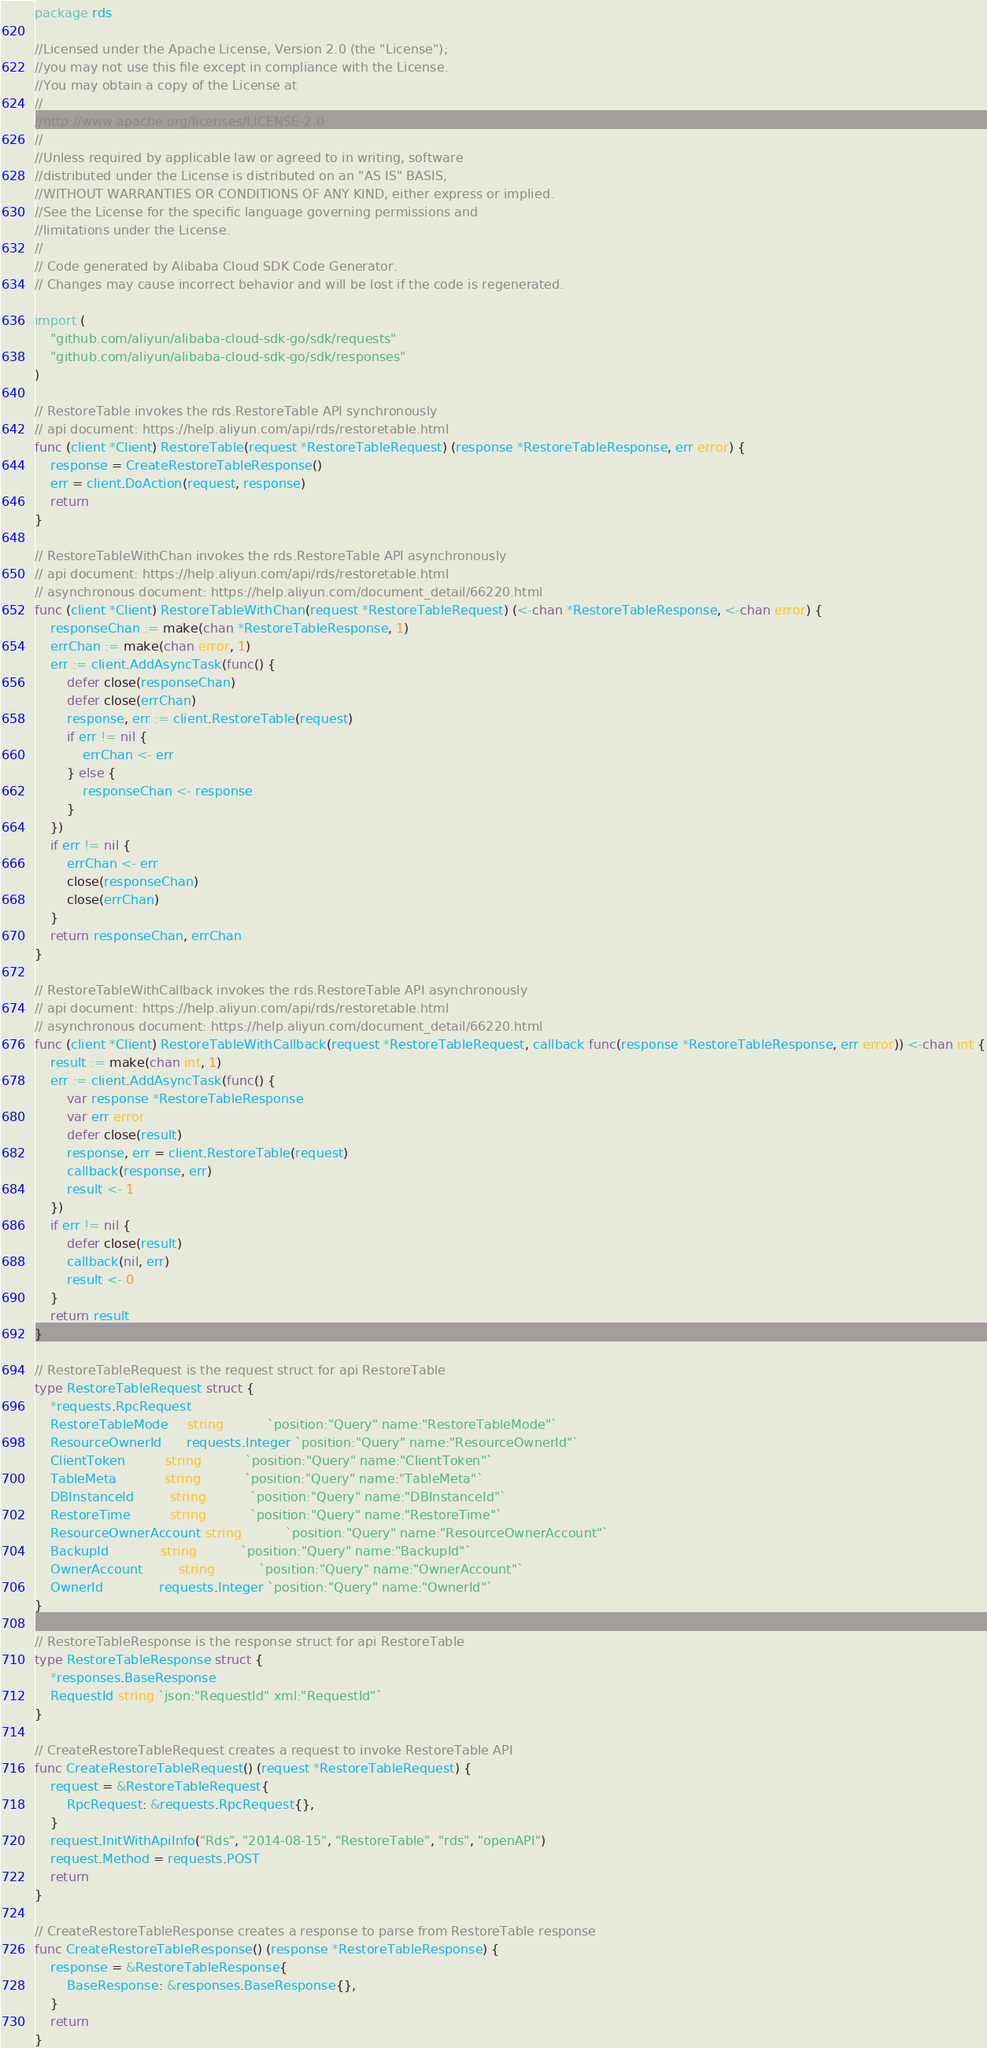Convert code to text. <code><loc_0><loc_0><loc_500><loc_500><_Go_>package rds

//Licensed under the Apache License, Version 2.0 (the "License");
//you may not use this file except in compliance with the License.
//You may obtain a copy of the License at
//
//http://www.apache.org/licenses/LICENSE-2.0
//
//Unless required by applicable law or agreed to in writing, software
//distributed under the License is distributed on an "AS IS" BASIS,
//WITHOUT WARRANTIES OR CONDITIONS OF ANY KIND, either express or implied.
//See the License for the specific language governing permissions and
//limitations under the License.
//
// Code generated by Alibaba Cloud SDK Code Generator.
// Changes may cause incorrect behavior and will be lost if the code is regenerated.

import (
	"github.com/aliyun/alibaba-cloud-sdk-go/sdk/requests"
	"github.com/aliyun/alibaba-cloud-sdk-go/sdk/responses"
)

// RestoreTable invokes the rds.RestoreTable API synchronously
// api document: https://help.aliyun.com/api/rds/restoretable.html
func (client *Client) RestoreTable(request *RestoreTableRequest) (response *RestoreTableResponse, err error) {
	response = CreateRestoreTableResponse()
	err = client.DoAction(request, response)
	return
}

// RestoreTableWithChan invokes the rds.RestoreTable API asynchronously
// api document: https://help.aliyun.com/api/rds/restoretable.html
// asynchronous document: https://help.aliyun.com/document_detail/66220.html
func (client *Client) RestoreTableWithChan(request *RestoreTableRequest) (<-chan *RestoreTableResponse, <-chan error) {
	responseChan := make(chan *RestoreTableResponse, 1)
	errChan := make(chan error, 1)
	err := client.AddAsyncTask(func() {
		defer close(responseChan)
		defer close(errChan)
		response, err := client.RestoreTable(request)
		if err != nil {
			errChan <- err
		} else {
			responseChan <- response
		}
	})
	if err != nil {
		errChan <- err
		close(responseChan)
		close(errChan)
	}
	return responseChan, errChan
}

// RestoreTableWithCallback invokes the rds.RestoreTable API asynchronously
// api document: https://help.aliyun.com/api/rds/restoretable.html
// asynchronous document: https://help.aliyun.com/document_detail/66220.html
func (client *Client) RestoreTableWithCallback(request *RestoreTableRequest, callback func(response *RestoreTableResponse, err error)) <-chan int {
	result := make(chan int, 1)
	err := client.AddAsyncTask(func() {
		var response *RestoreTableResponse
		var err error
		defer close(result)
		response, err = client.RestoreTable(request)
		callback(response, err)
		result <- 1
	})
	if err != nil {
		defer close(result)
		callback(nil, err)
		result <- 0
	}
	return result
}

// RestoreTableRequest is the request struct for api RestoreTable
type RestoreTableRequest struct {
	*requests.RpcRequest
	RestoreTableMode     string           `position:"Query" name:"RestoreTableMode"`
	ResourceOwnerId      requests.Integer `position:"Query" name:"ResourceOwnerId"`
	ClientToken          string           `position:"Query" name:"ClientToken"`
	TableMeta            string           `position:"Query" name:"TableMeta"`
	DBInstanceId         string           `position:"Query" name:"DBInstanceId"`
	RestoreTime          string           `position:"Query" name:"RestoreTime"`
	ResourceOwnerAccount string           `position:"Query" name:"ResourceOwnerAccount"`
	BackupId             string           `position:"Query" name:"BackupId"`
	OwnerAccount         string           `position:"Query" name:"OwnerAccount"`
	OwnerId              requests.Integer `position:"Query" name:"OwnerId"`
}

// RestoreTableResponse is the response struct for api RestoreTable
type RestoreTableResponse struct {
	*responses.BaseResponse
	RequestId string `json:"RequestId" xml:"RequestId"`
}

// CreateRestoreTableRequest creates a request to invoke RestoreTable API
func CreateRestoreTableRequest() (request *RestoreTableRequest) {
	request = &RestoreTableRequest{
		RpcRequest: &requests.RpcRequest{},
	}
	request.InitWithApiInfo("Rds", "2014-08-15", "RestoreTable", "rds", "openAPI")
	request.Method = requests.POST
	return
}

// CreateRestoreTableResponse creates a response to parse from RestoreTable response
func CreateRestoreTableResponse() (response *RestoreTableResponse) {
	response = &RestoreTableResponse{
		BaseResponse: &responses.BaseResponse{},
	}
	return
}
</code> 